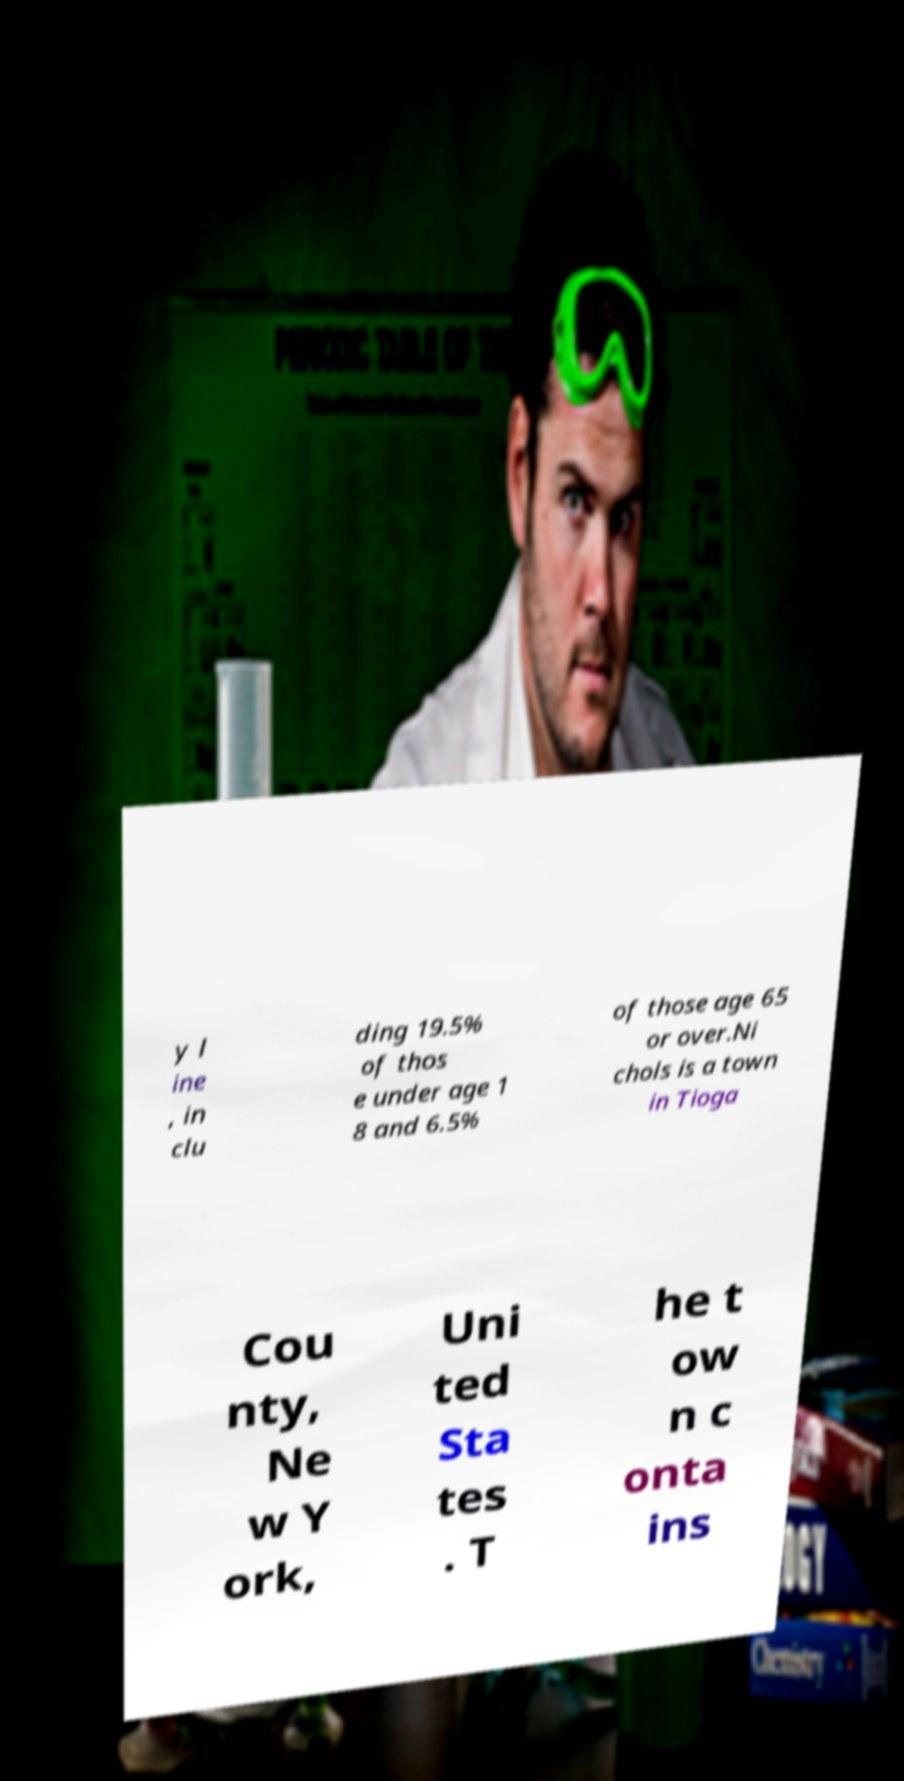Please read and relay the text visible in this image. What does it say? y l ine , in clu ding 19.5% of thos e under age 1 8 and 6.5% of those age 65 or over.Ni chols is a town in Tioga Cou nty, Ne w Y ork, Uni ted Sta tes . T he t ow n c onta ins 